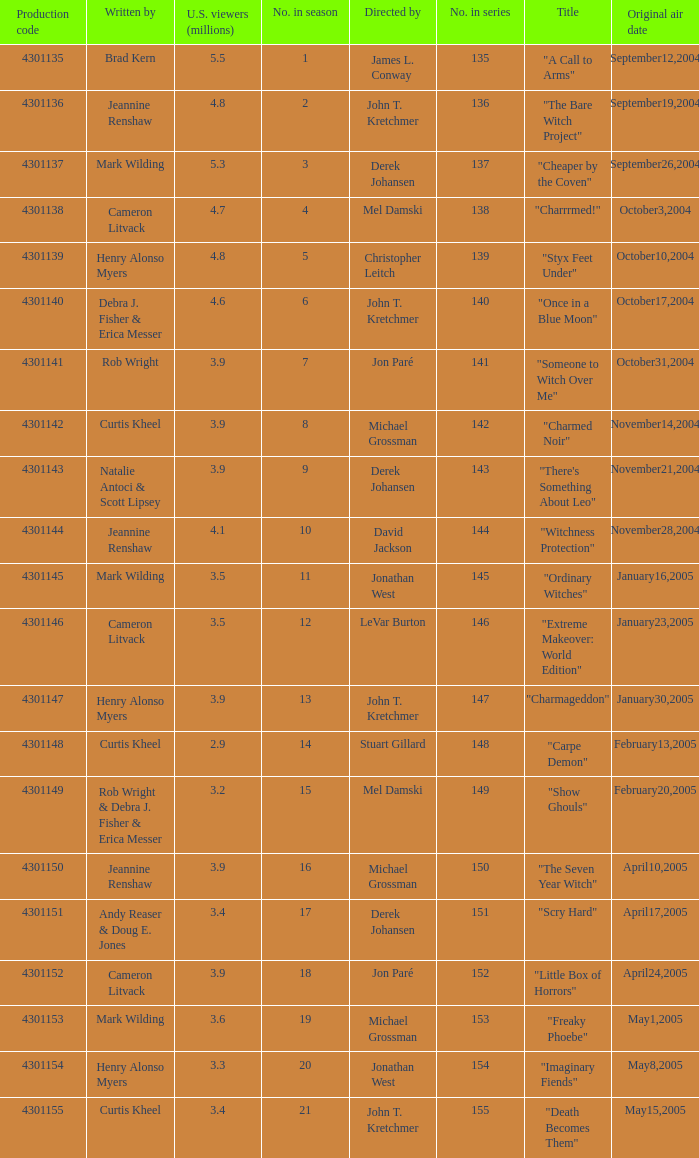Who were the directors of the episode called "someone to witch over me"? Jon Paré. 